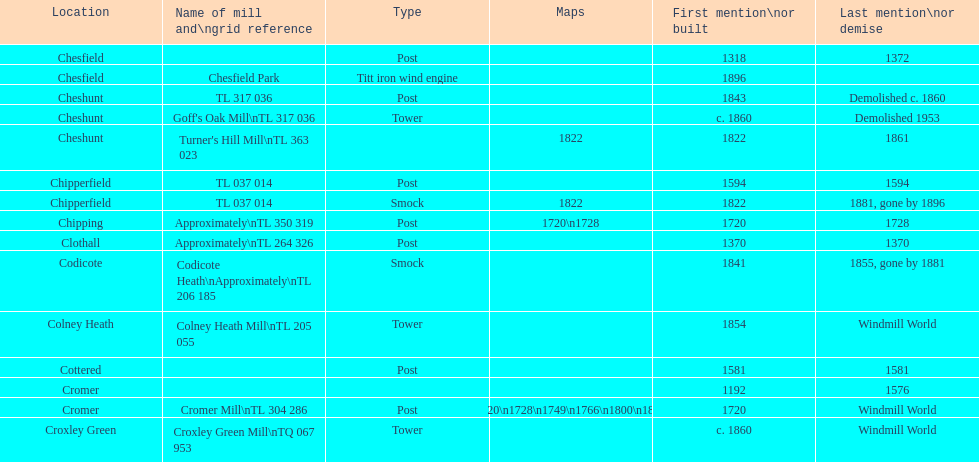What is the count of mills first referenced or built in the 1800s? 8. 